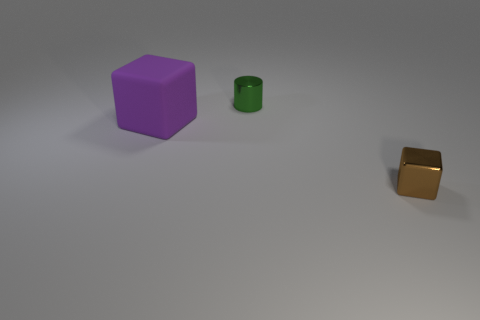Is there any other thing that has the same size as the purple rubber cube?
Provide a short and direct response. No. Is there any other thing that has the same shape as the tiny green thing?
Your answer should be very brief. No. What number of other objects are there of the same size as the brown thing?
Your answer should be compact. 1. There is a small thing in front of the purple rubber thing; is it the same shape as the large rubber object?
Offer a terse response. Yes. What number of other things are the same shape as the tiny green thing?
Provide a succinct answer. 0. There is a object in front of the large matte object; what shape is it?
Ensure brevity in your answer.  Cube. Is there a brown block that has the same material as the purple block?
Offer a terse response. No. Is the color of the small object behind the matte thing the same as the matte object?
Your answer should be very brief. No. How big is the brown block?
Make the answer very short. Small. There is a tiny metallic object that is in front of the block behind the small brown shiny object; is there a purple cube that is right of it?
Give a very brief answer. No. 